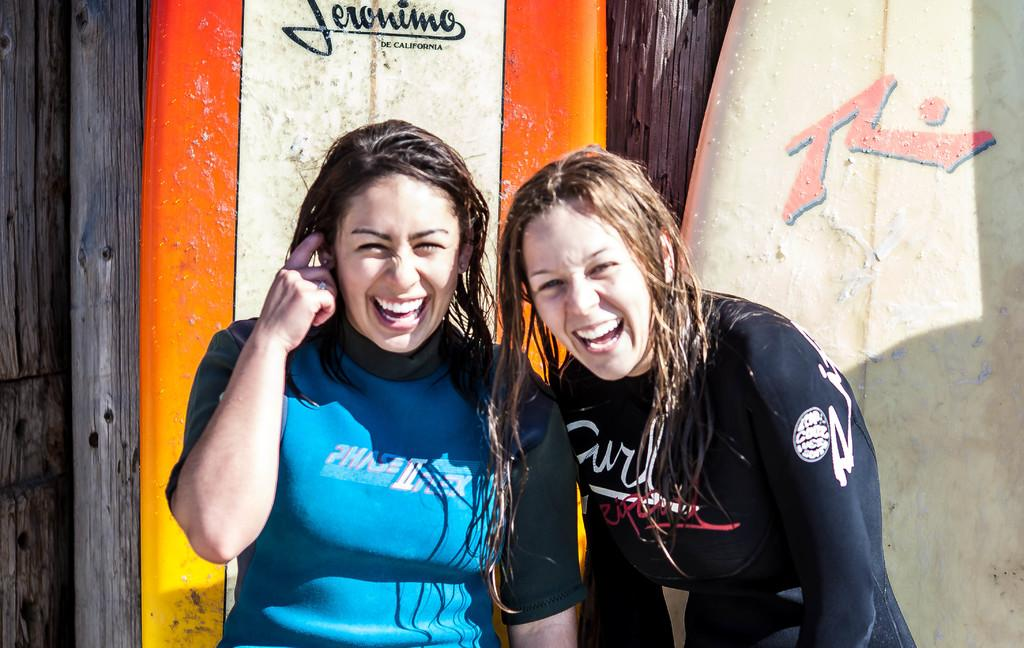How many people are in the image? There are two women in the image. What is the facial expression of the women? The women are smiling. What can be seen in the background of the image? There are surfboards and wooden poles in the background of the image. What type of music can be heard playing in the background of the image? There is no music present in the image, as it is a still photograph. 